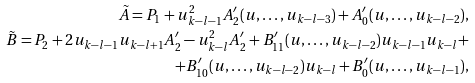<formula> <loc_0><loc_0><loc_500><loc_500>\tilde { A } = P _ { 1 } + u _ { k - l - 1 } ^ { 2 } A ^ { \prime } _ { 2 } ( u , \dots , u _ { k - l - 3 } ) + A ^ { \prime } _ { 0 } ( u , \dots , u _ { k - l - 2 } ) , \\ \tilde { B } = P _ { 2 } + 2 u _ { k - l - 1 } u _ { k - l + 1 } A ^ { \prime } _ { 2 } - u _ { k - l } ^ { 2 } A ^ { \prime } _ { 2 } + B ^ { \prime } _ { 1 1 } ( u , \dots , u _ { k - l - 2 } ) u _ { k - l - 1 } u _ { k - l } + \\ + B ^ { \prime } _ { 1 0 } ( u , \dots , u _ { k - l - 2 } ) u _ { k - l } + B ^ { \prime } _ { 0 } ( u , \dots , u _ { k - l - 1 } ) ,</formula> 